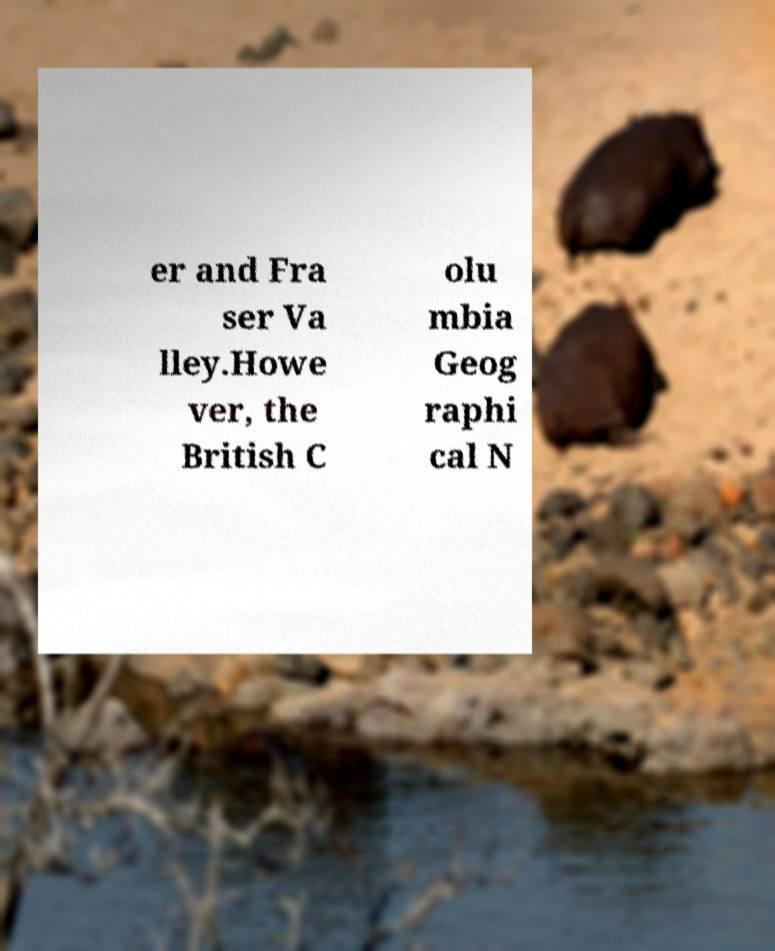Could you assist in decoding the text presented in this image and type it out clearly? er and Fra ser Va lley.Howe ver, the British C olu mbia Geog raphi cal N 